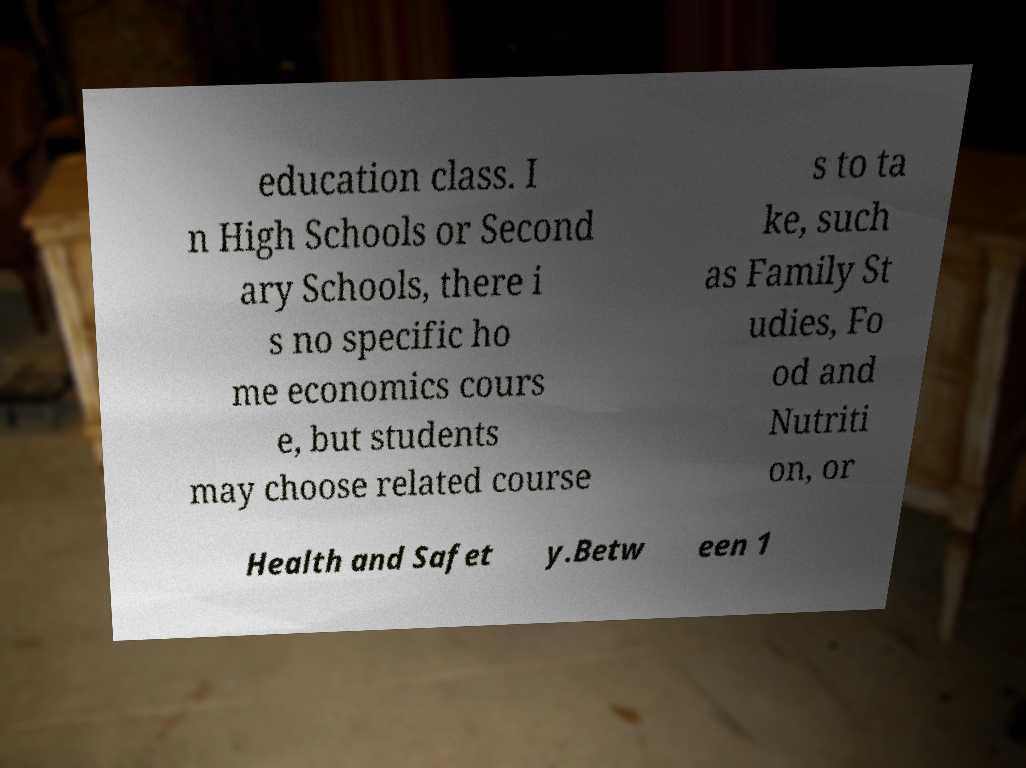Can you accurately transcribe the text from the provided image for me? education class. I n High Schools or Second ary Schools, there i s no specific ho me economics cours e, but students may choose related course s to ta ke, such as Family St udies, Fo od and Nutriti on, or Health and Safet y.Betw een 1 